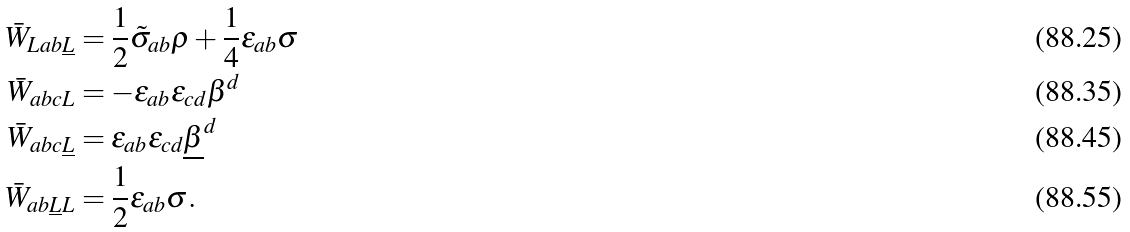<formula> <loc_0><loc_0><loc_500><loc_500>\bar { W } _ { L a b \underline { L } } & = \frac { 1 } { 2 } \tilde { \sigma } _ { a b } \rho + \frac { 1 } { 4 } \epsilon _ { a b } \sigma \\ \bar { W } _ { a b c L } & = - \epsilon _ { a b } \epsilon _ { c d } \beta ^ { d } \\ \bar { W } _ { a b c \underline { L } } & = \epsilon _ { a b } \epsilon _ { c d } \underline { \beta } ^ { d } \\ \bar { W } _ { a b \underline { L } L } & = \frac { 1 } { 2 } \epsilon _ { a b } \sigma .</formula> 